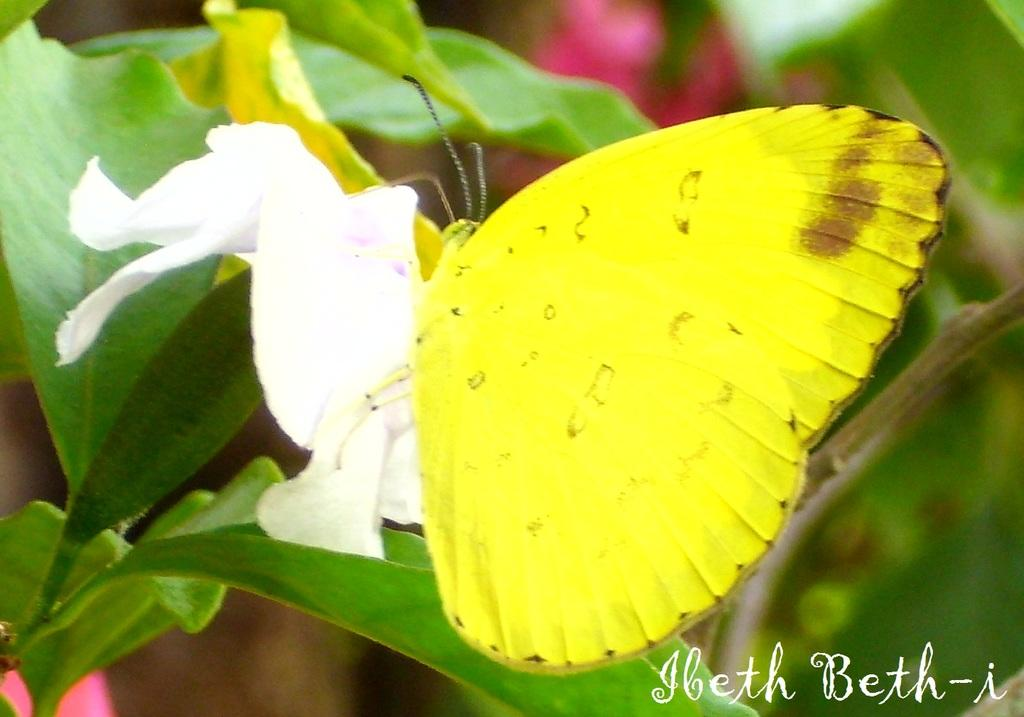What type of insect is present in the image? There is a butterfly in the image. What color is the butterfly? The butterfly is yellow. What type of plant is visible in the image? There is a white flower in the image. What is the color of the flower? The flower is white. What else can be seen in the image besides the butterfly and flower? There is a plant and text visible in the image. What type of rhythm can be heard in the image? There is no audible rhythm present in the image; it is a still image featuring a butterfly, white flower, plant, and text. 